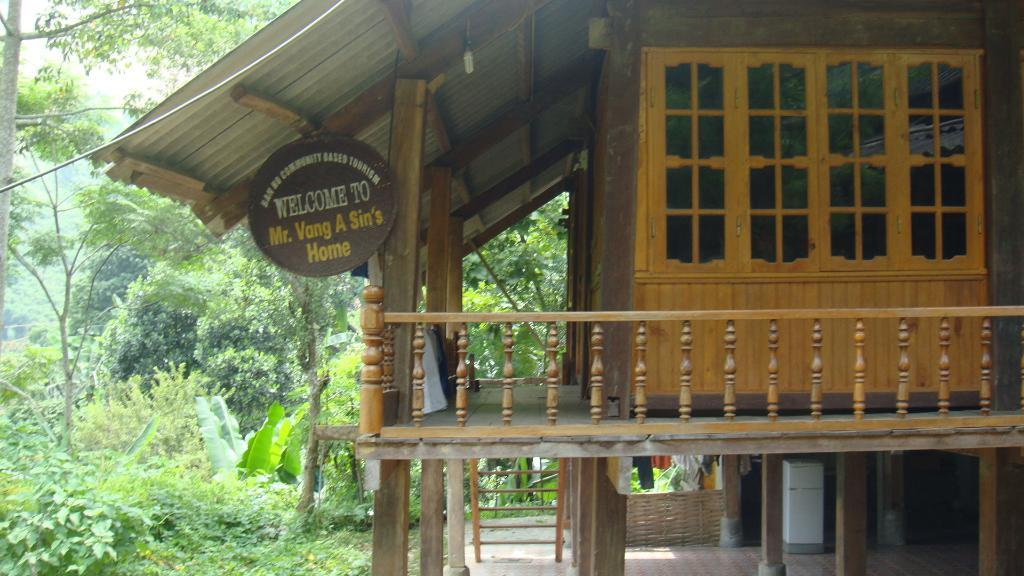What type of house is in the image? There is a wooden house in the image. What is on the wooden house? There is a board on the wooden house. What can be used to climb or reach higher places in the image? There is a ladder in the image. What provides illumination in the image? There is a light in the image. What type of barrier surrounds the property in the image? There is a wooden fence in the image. What color is the object in the image? There is a white color object in the image. What can be seen hanging or drying in the image? There are clothes visible in the image. What type of vegetation is on the left side of the image? There are trees on the left side of the image. What is the tendency of the oranges to grow on the wooden house in the image? There are no oranges present in the image, so it is not possible to determine their tendency to grow on the wooden house. 